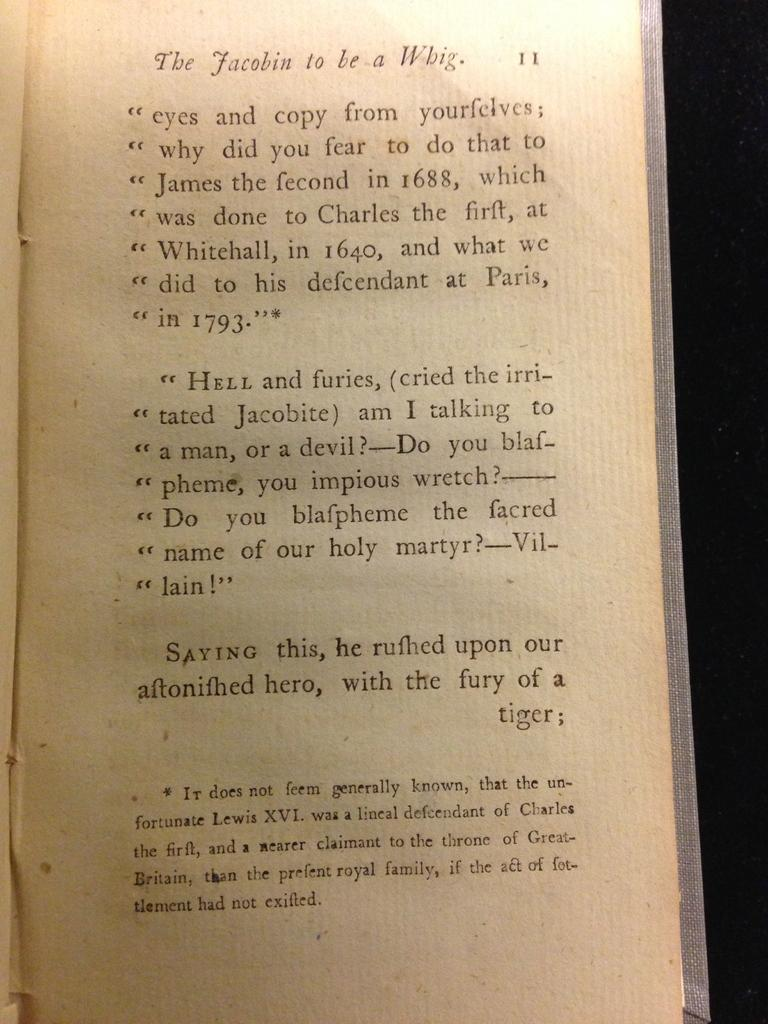<image>
Share a concise interpretation of the image provided. A passage from a book, with the title The Jacobin to be a Whig. 